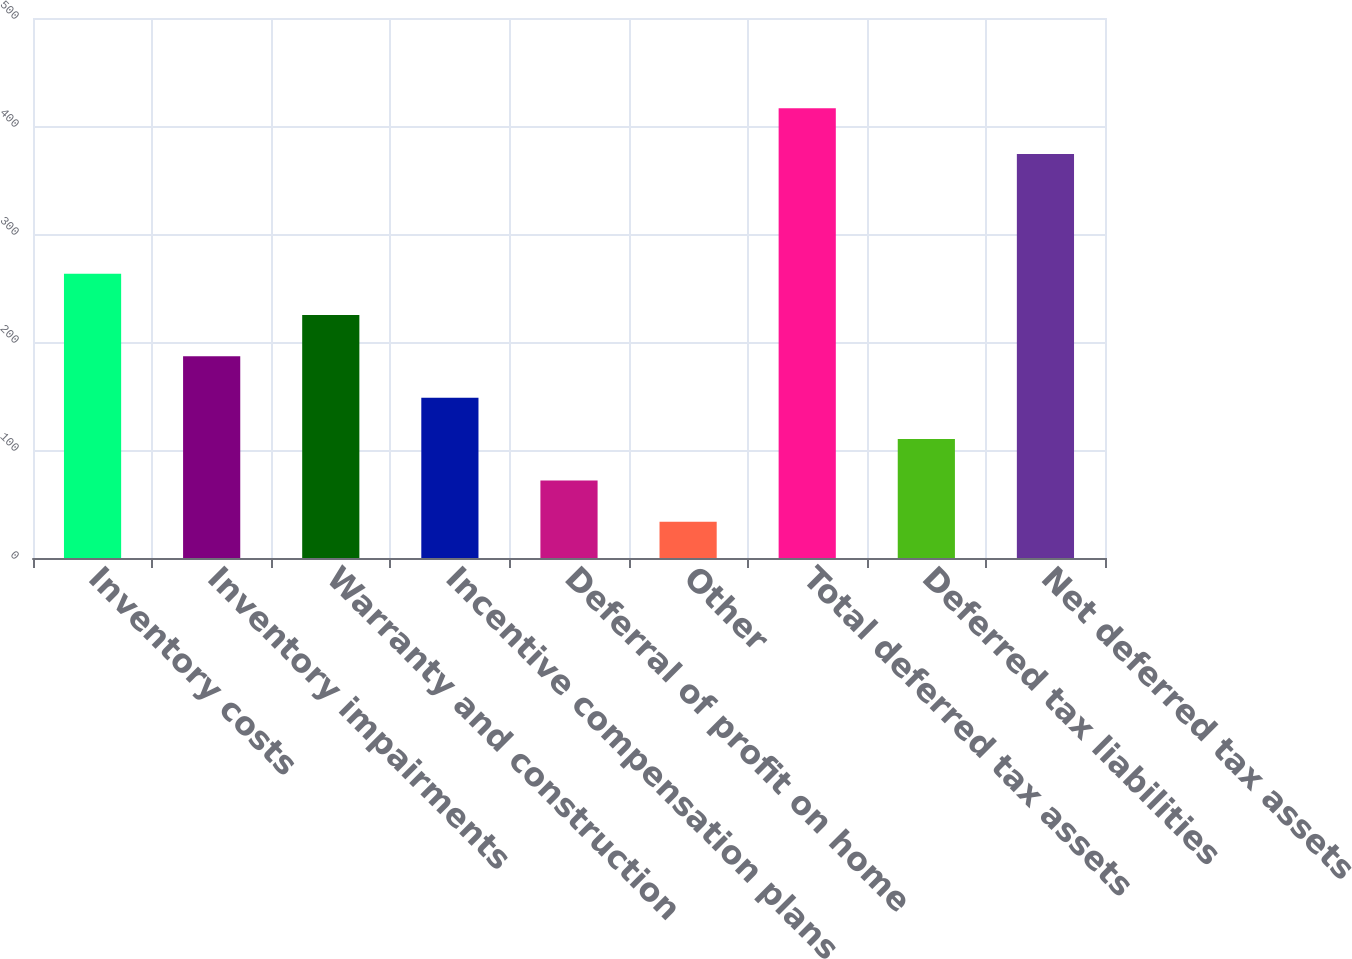<chart> <loc_0><loc_0><loc_500><loc_500><bar_chart><fcel>Inventory costs<fcel>Inventory impairments<fcel>Warranty and construction<fcel>Incentive compensation plans<fcel>Deferral of profit on home<fcel>Other<fcel>Total deferred tax assets<fcel>Deferred tax liabilities<fcel>Net deferred tax assets<nl><fcel>263.3<fcel>186.7<fcel>225<fcel>148.4<fcel>71.8<fcel>33.5<fcel>416.5<fcel>110.1<fcel>374<nl></chart> 